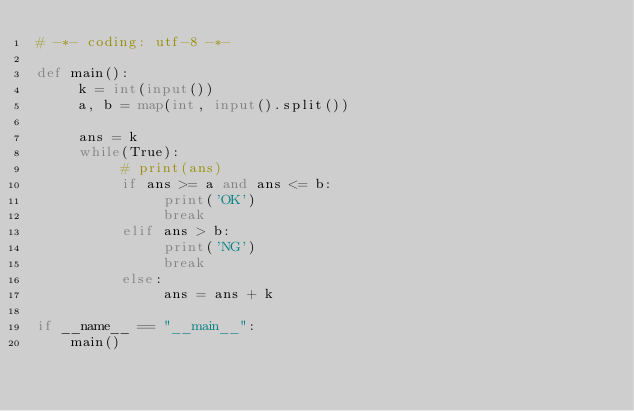<code> <loc_0><loc_0><loc_500><loc_500><_Python_># -*- coding: utf-8 -*-

def main():
     k = int(input())
     a, b = map(int, input().split())

     ans = k
     while(True):
          # print(ans)
          if ans >= a and ans <= b:
               print('OK')
               break
          elif ans > b:
               print('NG')
               break
          else:
               ans = ans + k

if __name__ == "__main__":
    main()
</code> 